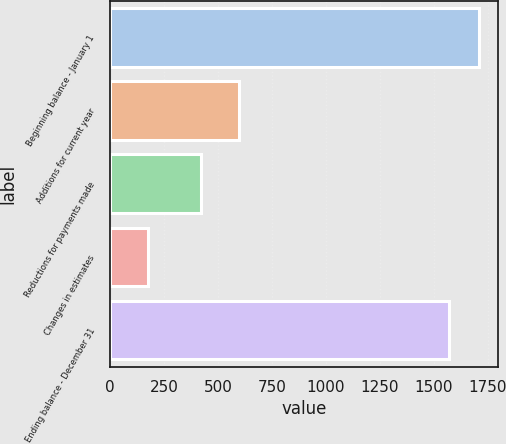Convert chart. <chart><loc_0><loc_0><loc_500><loc_500><bar_chart><fcel>Beginning balance - January 1<fcel>Additions for current year<fcel>Reductions for payments made<fcel>Changes in estimates<fcel>Ending balance - December 31<nl><fcel>1709.4<fcel>595<fcel>419<fcel>178<fcel>1570<nl></chart> 